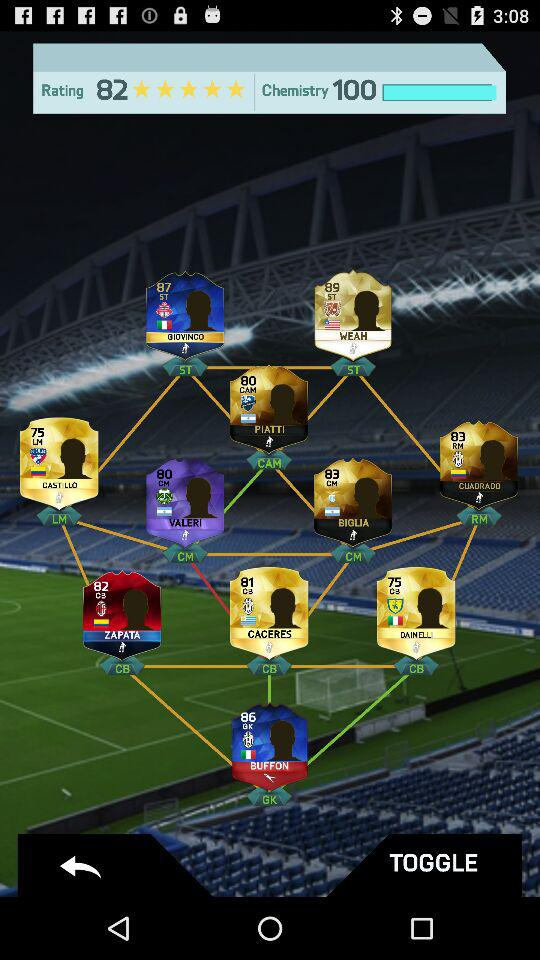How much is the rating? The rating is 5 stars. 